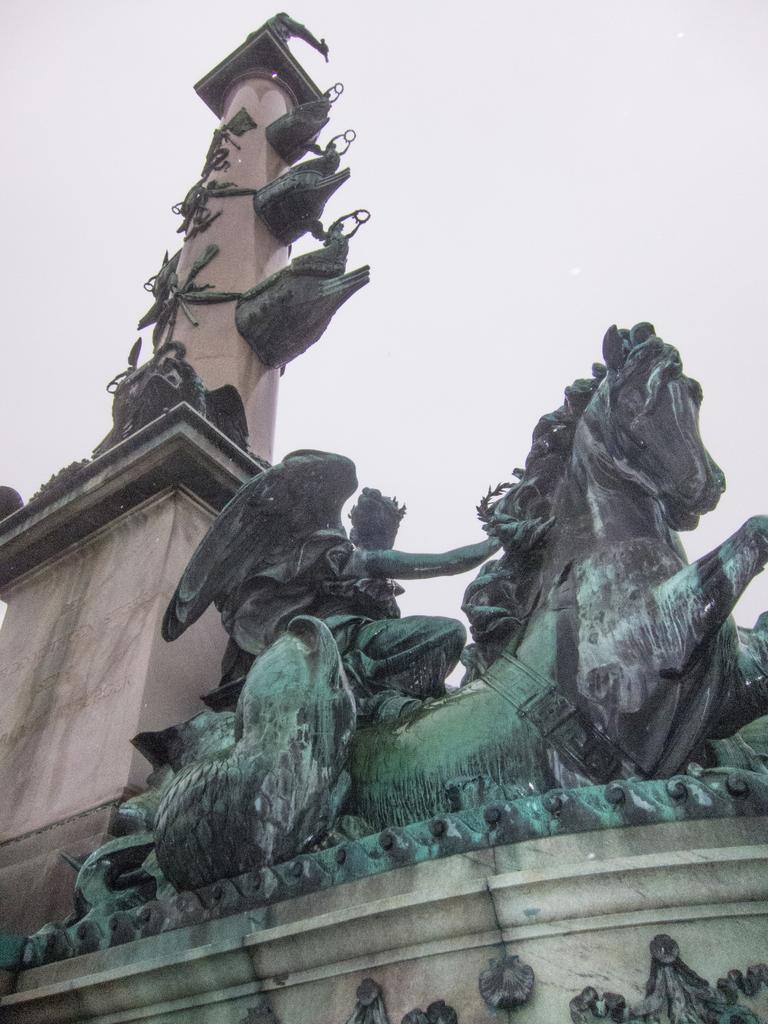Can you describe this image briefly? In this image there is a pillar and a sculpture, in the background there is sky. 